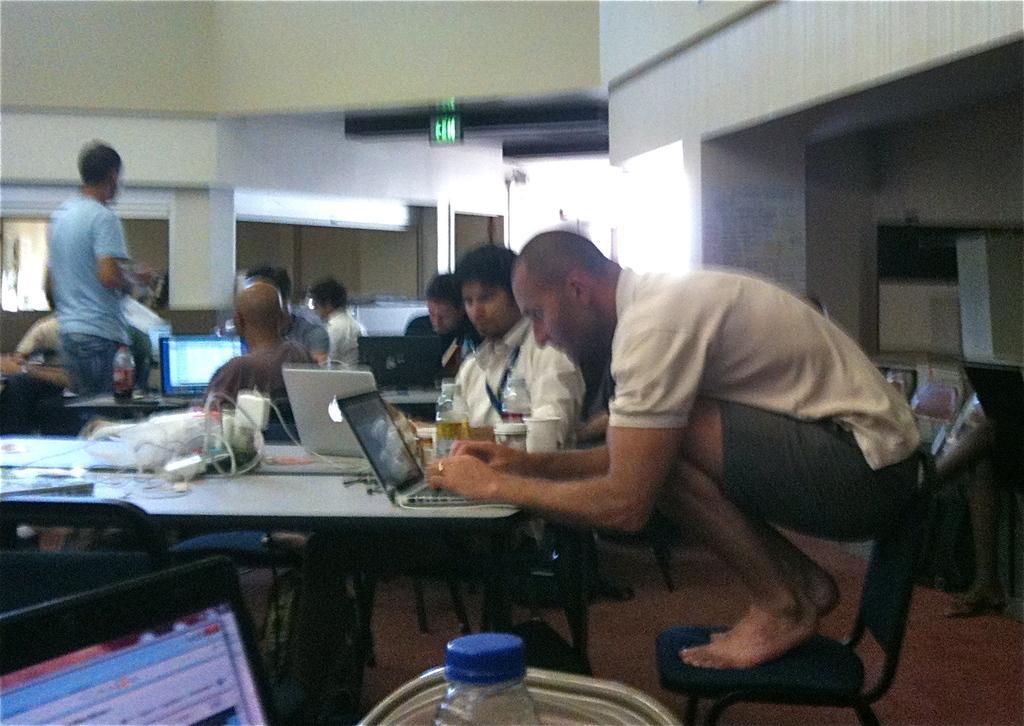Describe this image in one or two sentences. in the picture there is a room in that room people are sitting on the chair working with the laptop which is present on the tables which are in front of them a person is standing,on the table there are different items present on it. 